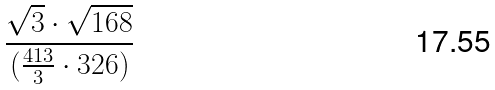<formula> <loc_0><loc_0><loc_500><loc_500>\frac { \sqrt { 3 } \cdot \sqrt { 1 6 8 } } { ( \frac { 4 1 3 } { 3 } \cdot 3 2 6 ) }</formula> 